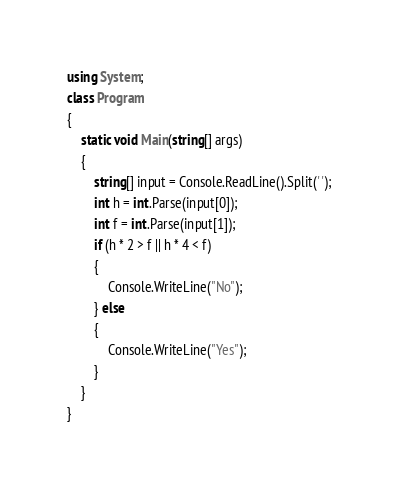<code> <loc_0><loc_0><loc_500><loc_500><_C#_>using System;
class Program
{
	static void Main(string[] args)
	{
		string[] input = Console.ReadLine().Split(' ');
		int h = int.Parse(input[0]);
		int f = int.Parse(input[1]);
        if (h * 2 > f || h * 4 < f)
        {
			Console.WriteLine("No");
        } else
        {
			Console.WriteLine("Yes");
        }
	}
}</code> 